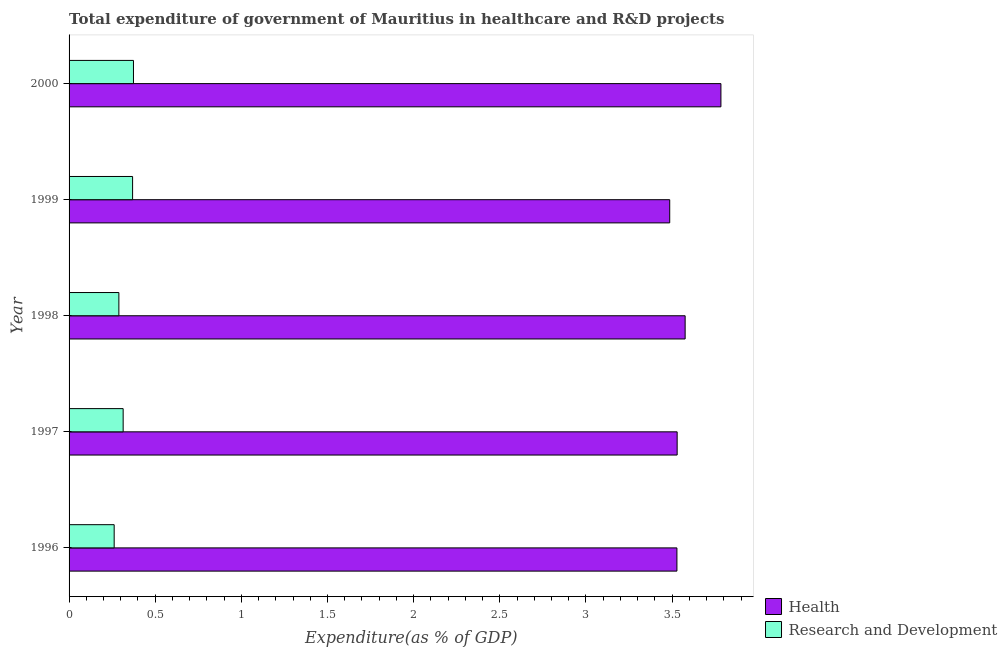How many different coloured bars are there?
Ensure brevity in your answer.  2. How many groups of bars are there?
Give a very brief answer. 5. Are the number of bars on each tick of the Y-axis equal?
Your answer should be very brief. Yes. How many bars are there on the 5th tick from the bottom?
Offer a terse response. 2. What is the label of the 5th group of bars from the top?
Your answer should be very brief. 1996. What is the expenditure in healthcare in 1998?
Your answer should be very brief. 3.58. Across all years, what is the maximum expenditure in r&d?
Provide a short and direct response. 0.37. Across all years, what is the minimum expenditure in r&d?
Ensure brevity in your answer.  0.26. What is the total expenditure in r&d in the graph?
Keep it short and to the point. 1.61. What is the difference between the expenditure in r&d in 1998 and that in 2000?
Offer a very short reply. -0.09. What is the difference between the expenditure in healthcare in 1997 and the expenditure in r&d in 1996?
Offer a very short reply. 3.27. What is the average expenditure in r&d per year?
Give a very brief answer. 0.32. In the year 1999, what is the difference between the expenditure in r&d and expenditure in healthcare?
Offer a very short reply. -3.12. What is the ratio of the expenditure in r&d in 1998 to that in 1999?
Offer a terse response. 0.78. Is the expenditure in healthcare in 1999 less than that in 2000?
Offer a very short reply. Yes. What is the difference between the highest and the second highest expenditure in healthcare?
Make the answer very short. 0.21. What does the 2nd bar from the top in 2000 represents?
Provide a succinct answer. Health. What does the 1st bar from the bottom in 1996 represents?
Offer a very short reply. Health. Does the graph contain any zero values?
Offer a very short reply. No. Does the graph contain grids?
Make the answer very short. No. Where does the legend appear in the graph?
Ensure brevity in your answer.  Bottom right. How many legend labels are there?
Your response must be concise. 2. How are the legend labels stacked?
Your response must be concise. Vertical. What is the title of the graph?
Make the answer very short. Total expenditure of government of Mauritius in healthcare and R&D projects. Does "ODA received" appear as one of the legend labels in the graph?
Provide a succinct answer. No. What is the label or title of the X-axis?
Offer a terse response. Expenditure(as % of GDP). What is the label or title of the Y-axis?
Your answer should be compact. Year. What is the Expenditure(as % of GDP) in Health in 1996?
Make the answer very short. 3.53. What is the Expenditure(as % of GDP) of Research and Development in 1996?
Offer a terse response. 0.26. What is the Expenditure(as % of GDP) of Health in 1997?
Keep it short and to the point. 3.53. What is the Expenditure(as % of GDP) in Research and Development in 1997?
Provide a short and direct response. 0.31. What is the Expenditure(as % of GDP) in Health in 1998?
Offer a terse response. 3.58. What is the Expenditure(as % of GDP) of Research and Development in 1998?
Your answer should be compact. 0.29. What is the Expenditure(as % of GDP) of Health in 1999?
Keep it short and to the point. 3.49. What is the Expenditure(as % of GDP) in Research and Development in 1999?
Offer a very short reply. 0.37. What is the Expenditure(as % of GDP) of Health in 2000?
Provide a short and direct response. 3.78. What is the Expenditure(as % of GDP) of Research and Development in 2000?
Your answer should be compact. 0.37. Across all years, what is the maximum Expenditure(as % of GDP) of Health?
Your answer should be compact. 3.78. Across all years, what is the maximum Expenditure(as % of GDP) of Research and Development?
Give a very brief answer. 0.37. Across all years, what is the minimum Expenditure(as % of GDP) in Health?
Offer a very short reply. 3.49. Across all years, what is the minimum Expenditure(as % of GDP) of Research and Development?
Keep it short and to the point. 0.26. What is the total Expenditure(as % of GDP) in Health in the graph?
Your answer should be compact. 17.9. What is the total Expenditure(as % of GDP) in Research and Development in the graph?
Offer a very short reply. 1.61. What is the difference between the Expenditure(as % of GDP) in Health in 1996 and that in 1997?
Provide a succinct answer. -0. What is the difference between the Expenditure(as % of GDP) in Research and Development in 1996 and that in 1997?
Give a very brief answer. -0.05. What is the difference between the Expenditure(as % of GDP) in Health in 1996 and that in 1998?
Make the answer very short. -0.05. What is the difference between the Expenditure(as % of GDP) in Research and Development in 1996 and that in 1998?
Give a very brief answer. -0.03. What is the difference between the Expenditure(as % of GDP) of Health in 1996 and that in 1999?
Give a very brief answer. 0.04. What is the difference between the Expenditure(as % of GDP) of Research and Development in 1996 and that in 1999?
Your answer should be very brief. -0.11. What is the difference between the Expenditure(as % of GDP) in Health in 1996 and that in 2000?
Make the answer very short. -0.26. What is the difference between the Expenditure(as % of GDP) of Research and Development in 1996 and that in 2000?
Your response must be concise. -0.11. What is the difference between the Expenditure(as % of GDP) of Health in 1997 and that in 1998?
Give a very brief answer. -0.05. What is the difference between the Expenditure(as % of GDP) of Research and Development in 1997 and that in 1998?
Keep it short and to the point. 0.02. What is the difference between the Expenditure(as % of GDP) in Health in 1997 and that in 1999?
Give a very brief answer. 0.04. What is the difference between the Expenditure(as % of GDP) in Research and Development in 1997 and that in 1999?
Give a very brief answer. -0.05. What is the difference between the Expenditure(as % of GDP) of Health in 1997 and that in 2000?
Make the answer very short. -0.25. What is the difference between the Expenditure(as % of GDP) in Research and Development in 1997 and that in 2000?
Your answer should be very brief. -0.06. What is the difference between the Expenditure(as % of GDP) of Health in 1998 and that in 1999?
Your answer should be very brief. 0.09. What is the difference between the Expenditure(as % of GDP) in Research and Development in 1998 and that in 1999?
Provide a short and direct response. -0.08. What is the difference between the Expenditure(as % of GDP) in Health in 1998 and that in 2000?
Make the answer very short. -0.21. What is the difference between the Expenditure(as % of GDP) of Research and Development in 1998 and that in 2000?
Your answer should be compact. -0.08. What is the difference between the Expenditure(as % of GDP) of Health in 1999 and that in 2000?
Offer a very short reply. -0.3. What is the difference between the Expenditure(as % of GDP) of Research and Development in 1999 and that in 2000?
Keep it short and to the point. -0.01. What is the difference between the Expenditure(as % of GDP) of Health in 1996 and the Expenditure(as % of GDP) of Research and Development in 1997?
Provide a succinct answer. 3.21. What is the difference between the Expenditure(as % of GDP) of Health in 1996 and the Expenditure(as % of GDP) of Research and Development in 1998?
Make the answer very short. 3.24. What is the difference between the Expenditure(as % of GDP) of Health in 1996 and the Expenditure(as % of GDP) of Research and Development in 1999?
Provide a succinct answer. 3.16. What is the difference between the Expenditure(as % of GDP) in Health in 1996 and the Expenditure(as % of GDP) in Research and Development in 2000?
Keep it short and to the point. 3.15. What is the difference between the Expenditure(as % of GDP) in Health in 1997 and the Expenditure(as % of GDP) in Research and Development in 1998?
Make the answer very short. 3.24. What is the difference between the Expenditure(as % of GDP) of Health in 1997 and the Expenditure(as % of GDP) of Research and Development in 1999?
Offer a very short reply. 3.16. What is the difference between the Expenditure(as % of GDP) of Health in 1997 and the Expenditure(as % of GDP) of Research and Development in 2000?
Provide a short and direct response. 3.16. What is the difference between the Expenditure(as % of GDP) in Health in 1998 and the Expenditure(as % of GDP) in Research and Development in 1999?
Ensure brevity in your answer.  3.21. What is the difference between the Expenditure(as % of GDP) of Health in 1998 and the Expenditure(as % of GDP) of Research and Development in 2000?
Provide a succinct answer. 3.2. What is the difference between the Expenditure(as % of GDP) of Health in 1999 and the Expenditure(as % of GDP) of Research and Development in 2000?
Offer a terse response. 3.11. What is the average Expenditure(as % of GDP) in Health per year?
Ensure brevity in your answer.  3.58. What is the average Expenditure(as % of GDP) in Research and Development per year?
Your answer should be compact. 0.32. In the year 1996, what is the difference between the Expenditure(as % of GDP) in Health and Expenditure(as % of GDP) in Research and Development?
Offer a terse response. 3.27. In the year 1997, what is the difference between the Expenditure(as % of GDP) in Health and Expenditure(as % of GDP) in Research and Development?
Ensure brevity in your answer.  3.22. In the year 1998, what is the difference between the Expenditure(as % of GDP) of Health and Expenditure(as % of GDP) of Research and Development?
Your answer should be compact. 3.29. In the year 1999, what is the difference between the Expenditure(as % of GDP) of Health and Expenditure(as % of GDP) of Research and Development?
Your response must be concise. 3.12. In the year 2000, what is the difference between the Expenditure(as % of GDP) in Health and Expenditure(as % of GDP) in Research and Development?
Provide a short and direct response. 3.41. What is the ratio of the Expenditure(as % of GDP) in Health in 1996 to that in 1997?
Your answer should be very brief. 1. What is the ratio of the Expenditure(as % of GDP) in Research and Development in 1996 to that in 1997?
Provide a succinct answer. 0.83. What is the ratio of the Expenditure(as % of GDP) of Health in 1996 to that in 1998?
Your response must be concise. 0.99. What is the ratio of the Expenditure(as % of GDP) of Research and Development in 1996 to that in 1998?
Ensure brevity in your answer.  0.91. What is the ratio of the Expenditure(as % of GDP) of Health in 1996 to that in 1999?
Give a very brief answer. 1.01. What is the ratio of the Expenditure(as % of GDP) of Research and Development in 1996 to that in 1999?
Your answer should be compact. 0.71. What is the ratio of the Expenditure(as % of GDP) of Health in 1996 to that in 2000?
Offer a terse response. 0.93. What is the ratio of the Expenditure(as % of GDP) in Research and Development in 1996 to that in 2000?
Keep it short and to the point. 0.7. What is the ratio of the Expenditure(as % of GDP) of Health in 1997 to that in 1998?
Keep it short and to the point. 0.99. What is the ratio of the Expenditure(as % of GDP) in Research and Development in 1997 to that in 1998?
Your answer should be very brief. 1.09. What is the ratio of the Expenditure(as % of GDP) in Health in 1997 to that in 1999?
Keep it short and to the point. 1.01. What is the ratio of the Expenditure(as % of GDP) in Research and Development in 1997 to that in 1999?
Your answer should be compact. 0.85. What is the ratio of the Expenditure(as % of GDP) of Health in 1997 to that in 2000?
Provide a short and direct response. 0.93. What is the ratio of the Expenditure(as % of GDP) in Research and Development in 1997 to that in 2000?
Provide a succinct answer. 0.84. What is the ratio of the Expenditure(as % of GDP) of Health in 1998 to that in 1999?
Offer a very short reply. 1.03. What is the ratio of the Expenditure(as % of GDP) in Research and Development in 1998 to that in 1999?
Your answer should be compact. 0.78. What is the ratio of the Expenditure(as % of GDP) of Health in 1998 to that in 2000?
Keep it short and to the point. 0.95. What is the ratio of the Expenditure(as % of GDP) of Research and Development in 1998 to that in 2000?
Offer a terse response. 0.77. What is the ratio of the Expenditure(as % of GDP) in Health in 1999 to that in 2000?
Keep it short and to the point. 0.92. What is the ratio of the Expenditure(as % of GDP) of Research and Development in 1999 to that in 2000?
Offer a very short reply. 0.99. What is the difference between the highest and the second highest Expenditure(as % of GDP) of Health?
Make the answer very short. 0.21. What is the difference between the highest and the second highest Expenditure(as % of GDP) in Research and Development?
Provide a succinct answer. 0.01. What is the difference between the highest and the lowest Expenditure(as % of GDP) in Health?
Keep it short and to the point. 0.3. What is the difference between the highest and the lowest Expenditure(as % of GDP) of Research and Development?
Offer a terse response. 0.11. 